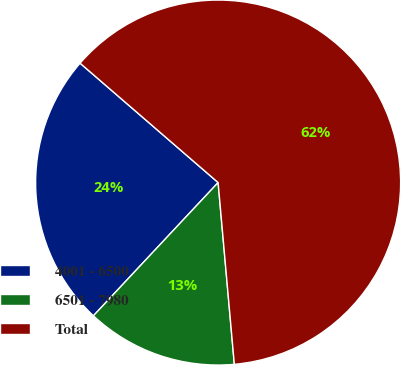Convert chart. <chart><loc_0><loc_0><loc_500><loc_500><pie_chart><fcel>4001 - 6500<fcel>6501 - 7980<fcel>Total<nl><fcel>24.37%<fcel>13.39%<fcel>62.23%<nl></chart> 